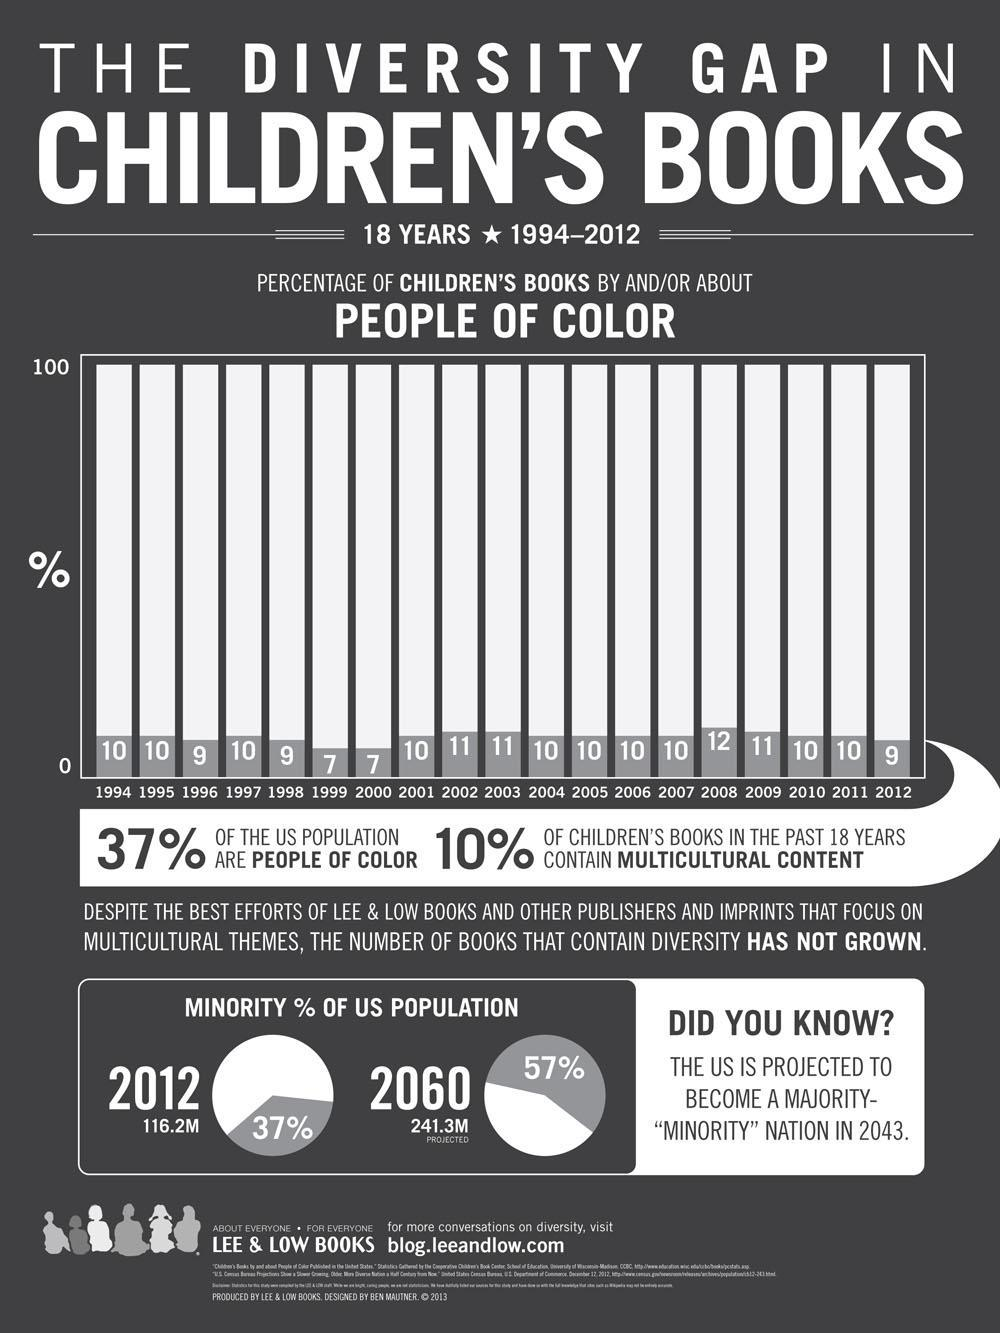What percentage of the US population are colored people?
Answer the question with a short phrase. 63% In which all years the percentage of children's books is about people of color? 1996, 1998, 2012 What is the highest percentage of children's books about people of color? 12% What percentage of children's books does not contain multicultural content? 90% 